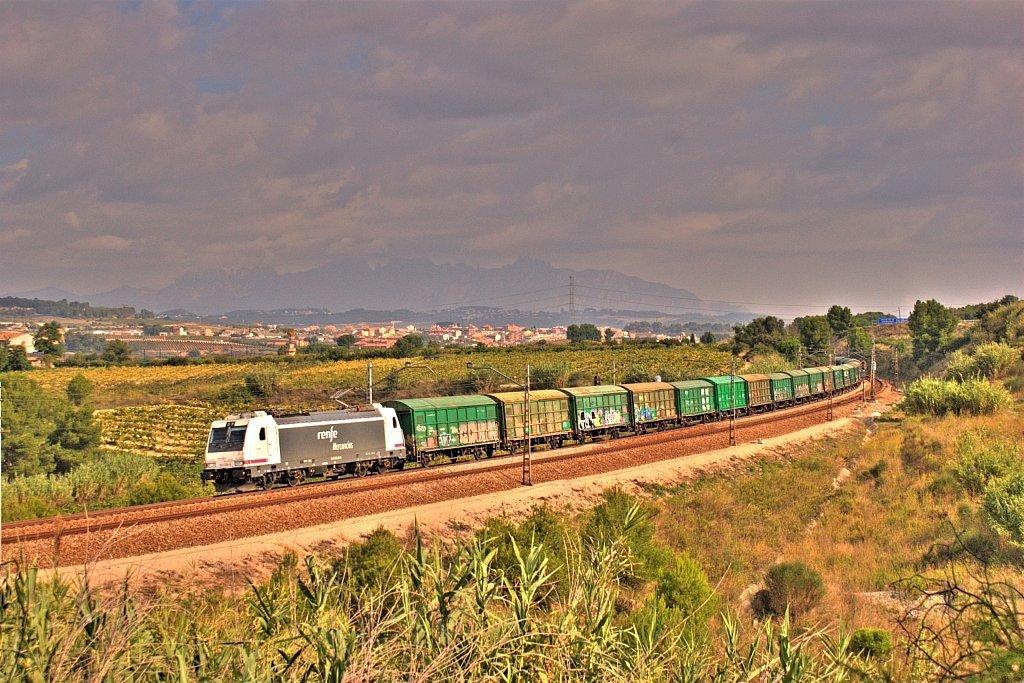Can you describe this image briefly? This image is taken outdoors. At the top of the image there is a sky with clouds. In the background there are a few hills. There are a few houses, trees and plants on the ground and there is a tower with wires. In the middle of the image a train is moving on the track. There are a few poles. There are many trees and plants and there is a ground with grass on it. At the bottom of the image there are many plants on the ground. 